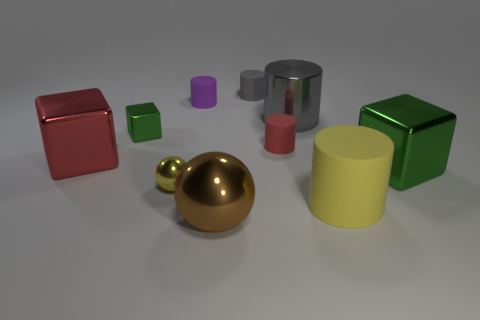Does the tiny yellow thing have the same material as the green block on the right side of the large gray cylinder?
Provide a short and direct response. Yes. What number of metal objects are both to the left of the tiny ball and behind the big red cube?
Your answer should be compact. 1. There is a green object that is the same size as the gray rubber cylinder; what shape is it?
Your answer should be very brief. Cube. Are there any tiny rubber things that are left of the large metallic thing that is in front of the large cube to the right of the tiny gray object?
Keep it short and to the point. Yes. Do the small shiny ball and the big cylinder that is in front of the tiny green block have the same color?
Offer a terse response. Yes. What number of small rubber cylinders are the same color as the large shiny cylinder?
Ensure brevity in your answer.  1. What size is the cylinder in front of the block that is on the right side of the gray matte cylinder?
Your response must be concise. Large. What number of objects are red objects to the right of the small yellow shiny sphere or tiny cubes?
Ensure brevity in your answer.  2. Is there a shiny object of the same size as the brown sphere?
Provide a short and direct response. Yes. There is a yellow thing that is to the left of the tiny gray object; are there any purple rubber cylinders that are behind it?
Offer a terse response. Yes. 